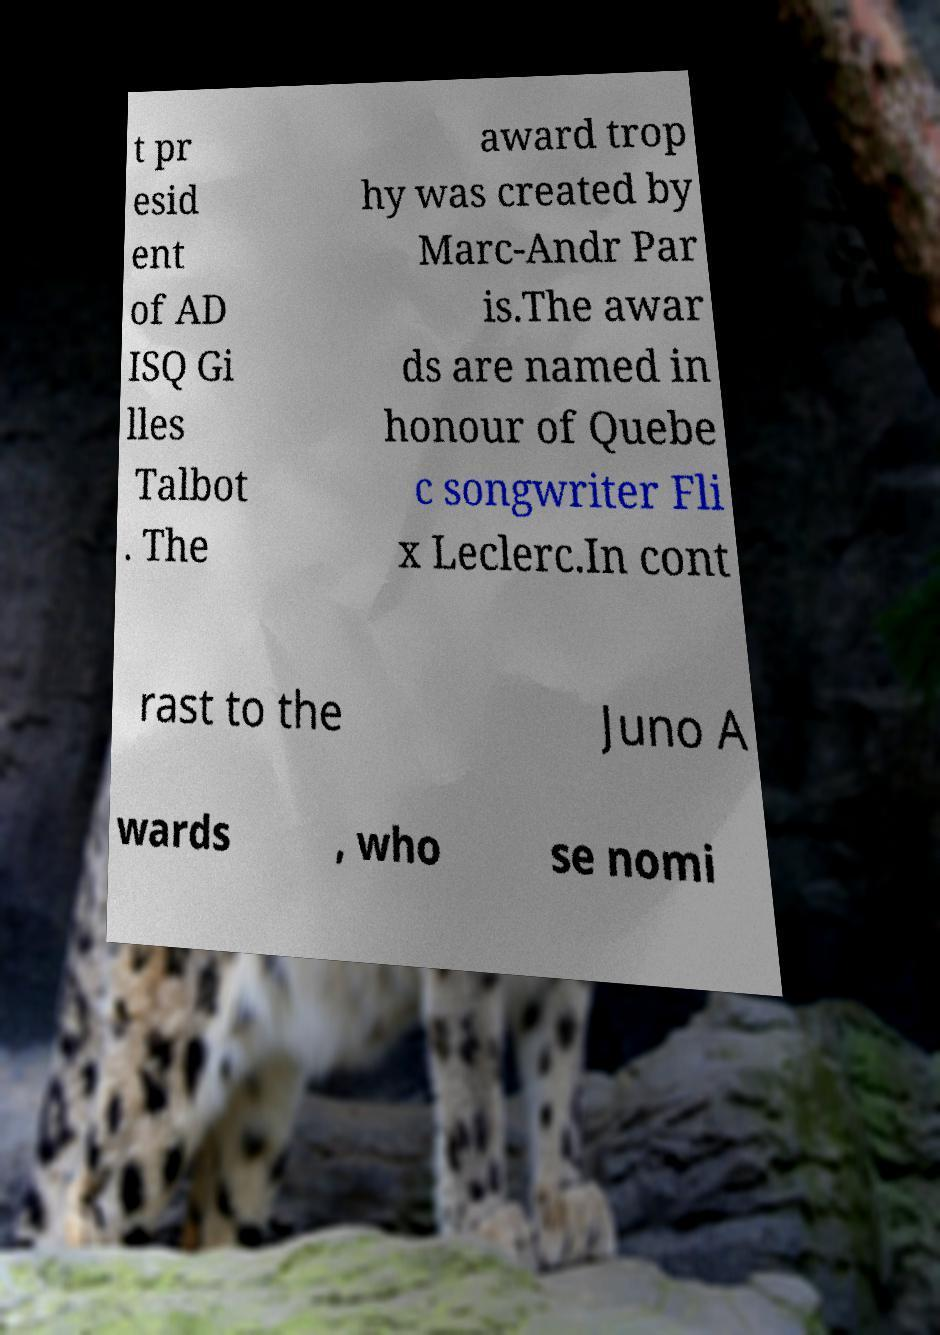Can you read and provide the text displayed in the image?This photo seems to have some interesting text. Can you extract and type it out for me? t pr esid ent of AD ISQ Gi lles Talbot . The award trop hy was created by Marc-Andr Par is.The awar ds are named in honour of Quebe c songwriter Fli x Leclerc.In cont rast to the Juno A wards , who se nomi 